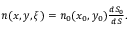Convert formula to latex. <formula><loc_0><loc_0><loc_500><loc_500>\begin{array} { r } { n ( x , y , \xi ) = n _ { 0 } ( x _ { 0 } , y _ { 0 } ) \frac { d S _ { 0 } } { d S } . } \end{array}</formula> 